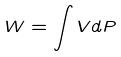<formula> <loc_0><loc_0><loc_500><loc_500>W = \int V d P</formula> 